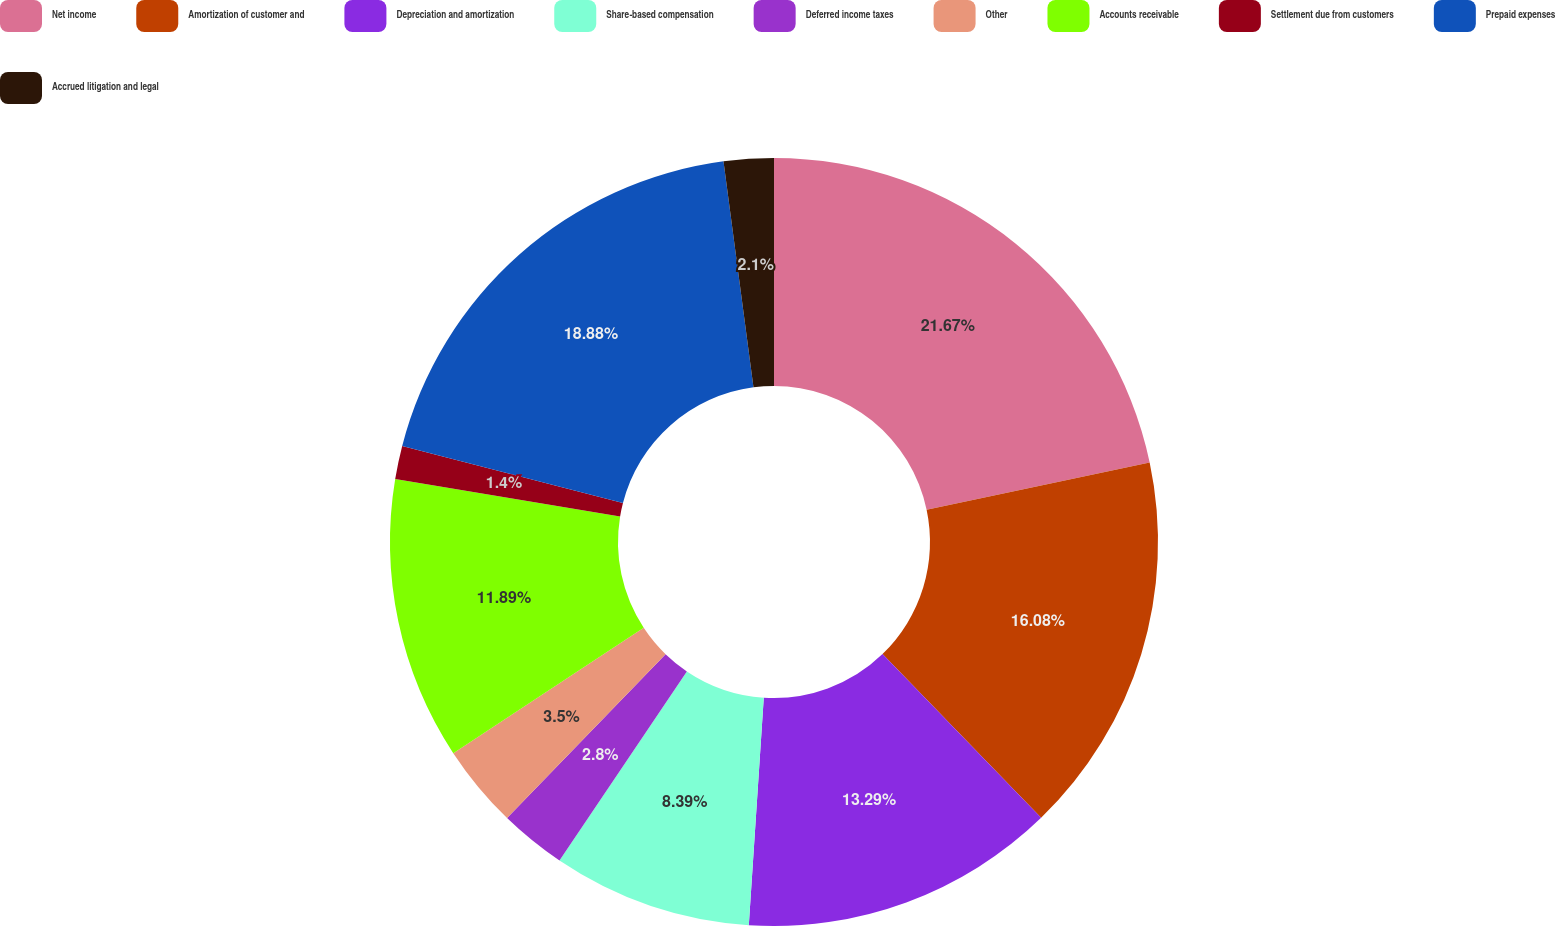Convert chart. <chart><loc_0><loc_0><loc_500><loc_500><pie_chart><fcel>Net income<fcel>Amortization of customer and<fcel>Depreciation and amortization<fcel>Share-based compensation<fcel>Deferred income taxes<fcel>Other<fcel>Accounts receivable<fcel>Settlement due from customers<fcel>Prepaid expenses<fcel>Accrued litigation and legal<nl><fcel>21.68%<fcel>16.08%<fcel>13.29%<fcel>8.39%<fcel>2.8%<fcel>3.5%<fcel>11.89%<fcel>1.4%<fcel>18.88%<fcel>2.1%<nl></chart> 